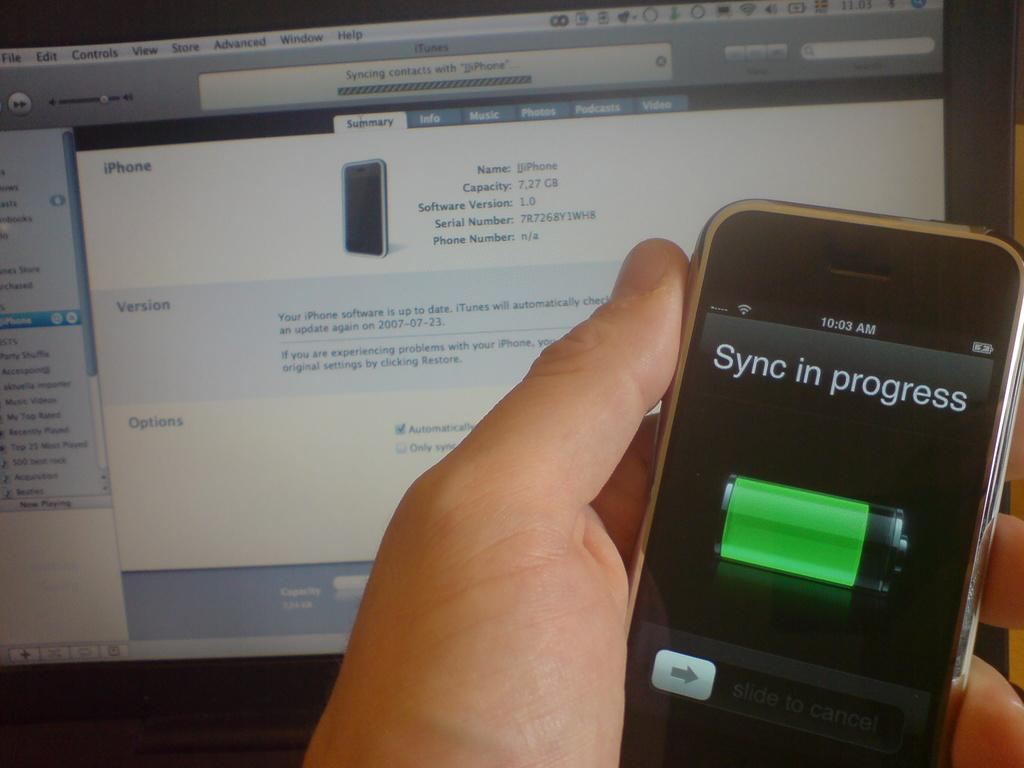<image>
Present a compact description of the photo's key features. A smartphone held by a person with a the words Sync in process on the display screen 